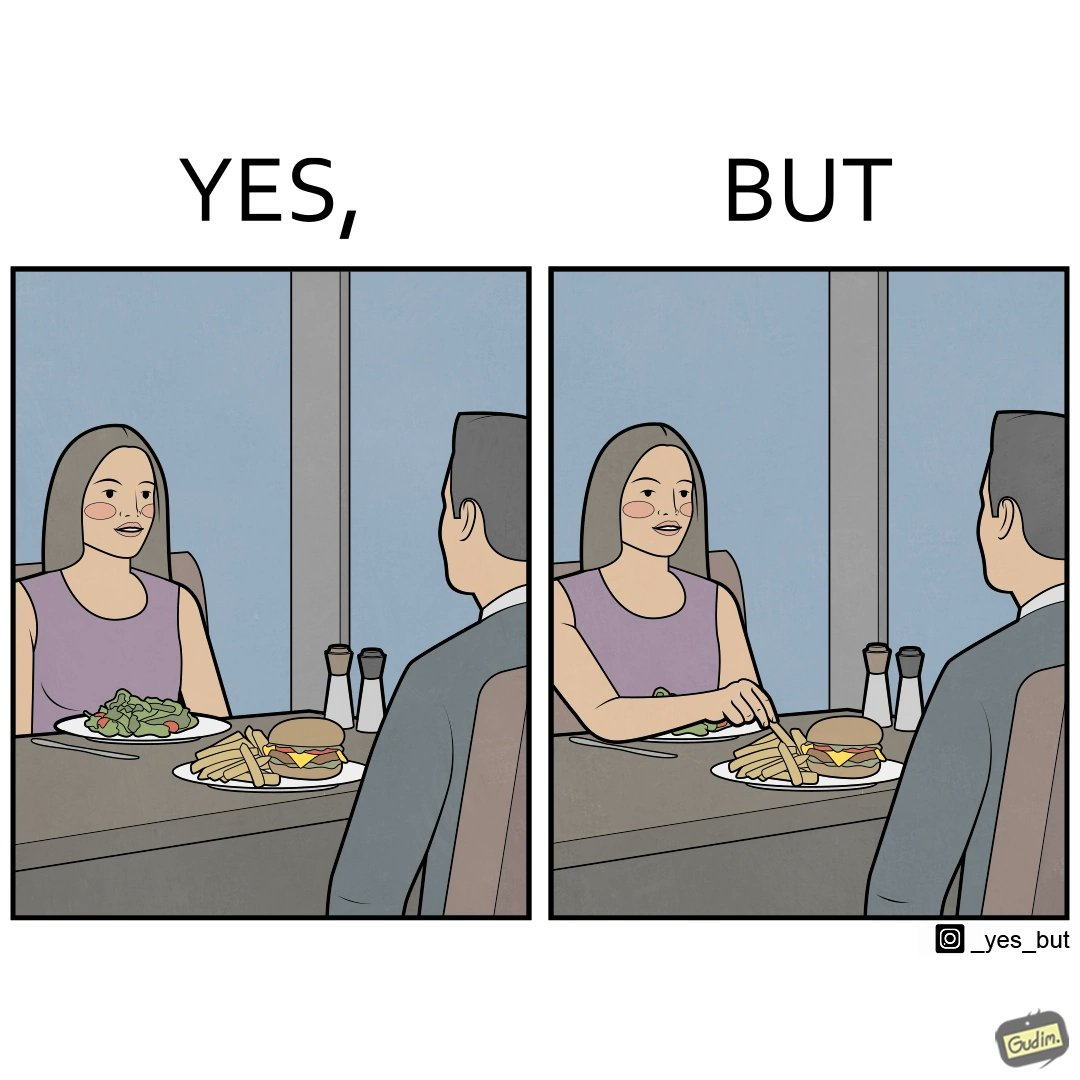What do you see in each half of this image? In the left part of the image: a woman and a man having their meals at some restaurant, with a plate of salad on the woman's side and a burger and french fries on the man's side on the table In the right part of the image: a woman and a man having their meals at some restaurant, with a plate of salad on the woman's side and a burger and french fries on the man's side on the table and the woman is having the french fries from the man's plate 